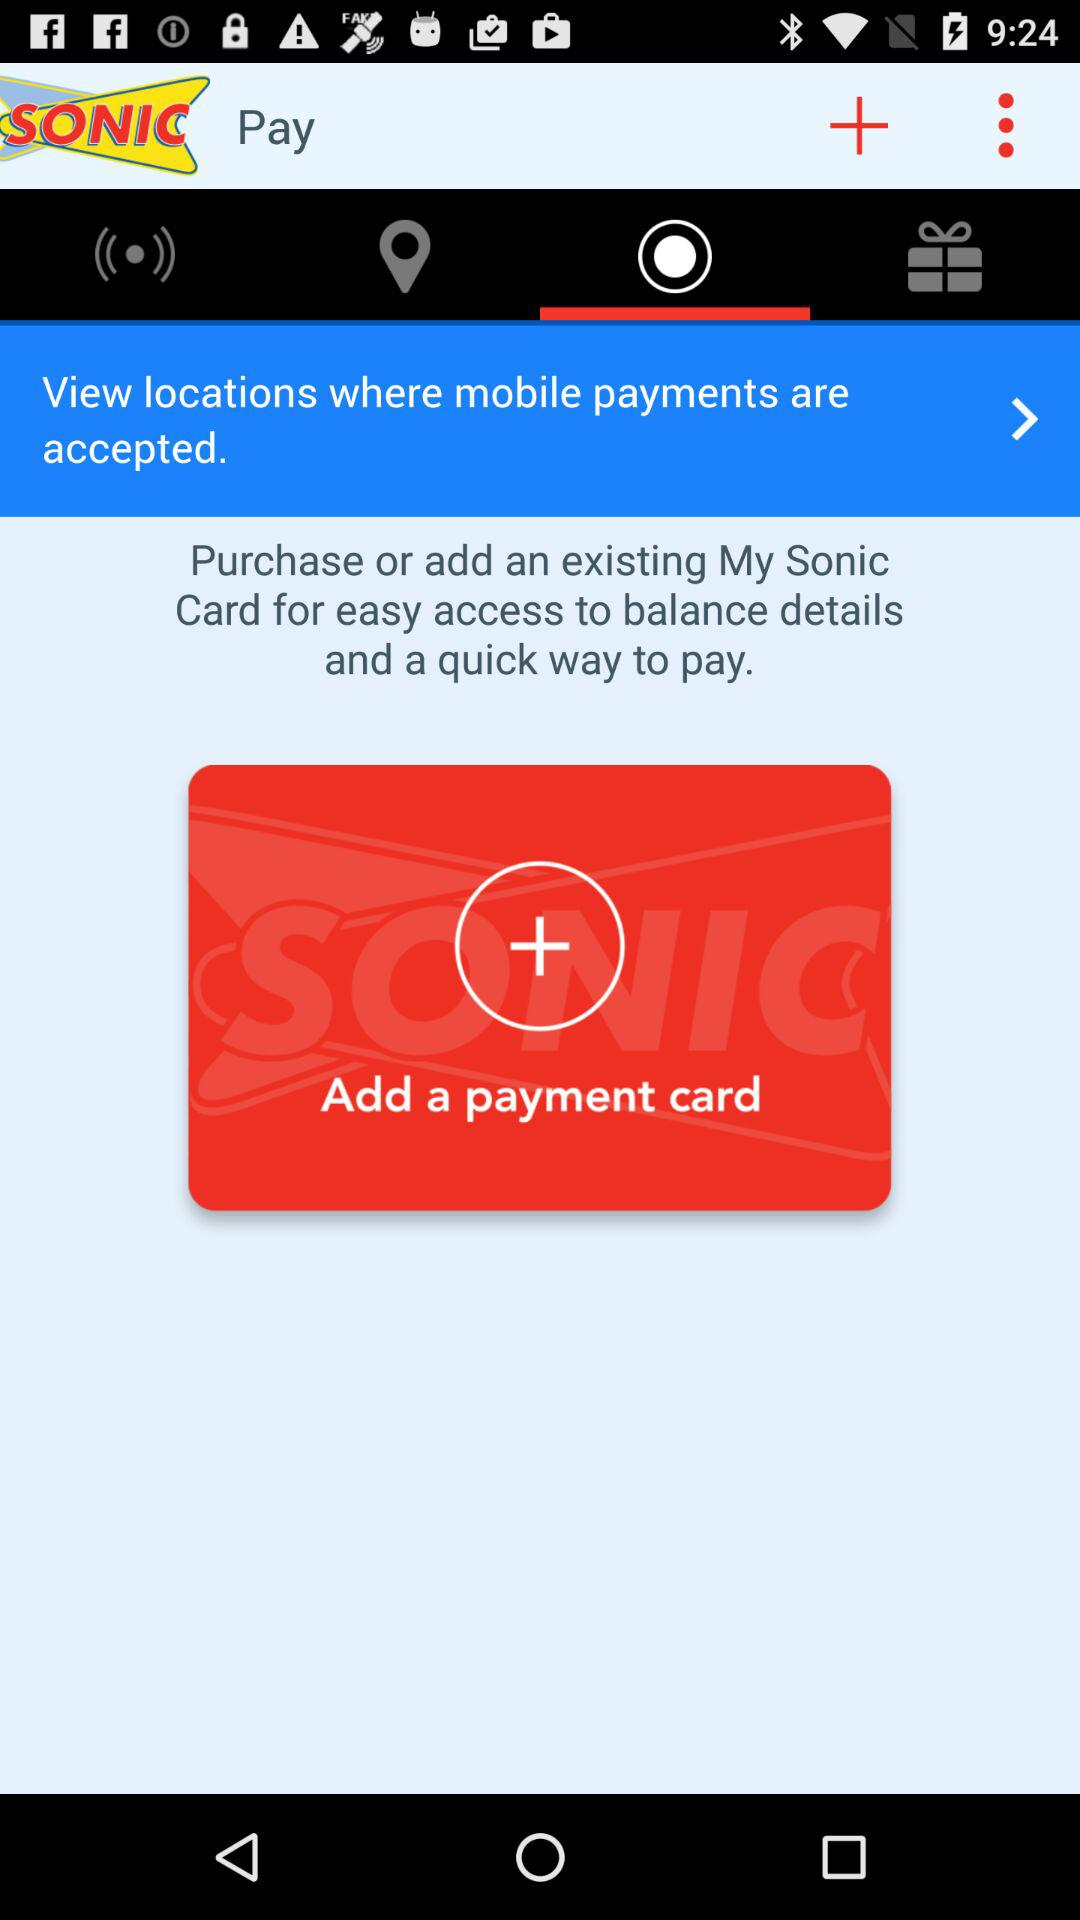What is the number of the payment card that is added?
When the provided information is insufficient, respond with <no answer>. <no answer> 